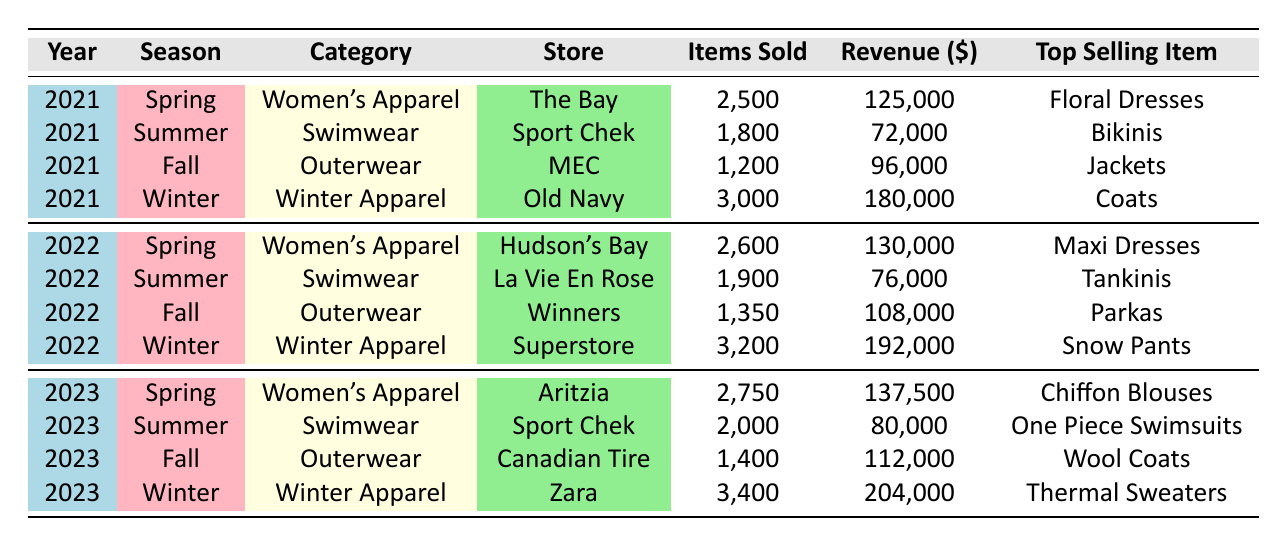What was the top-selling item in Winter 2022? According to the table, in Winter 2022, the top-selling item was "Snow Pants" sold at Superstore.
Answer: Snow Pants How many items of Women’s Apparel were sold in Spring 2023? The table indicates that in Spring 2023, 2,750 items of Women's Apparel were sold at Aritzia.
Answer: 2750 Which store sold the highest number of swimwear items in Summer 2023? In Summer 2023, Sport Chek sold 2,000 items of swimwear, which is the highest among the listed stores for that season.
Answer: Sport Chek What is the total revenue generated from Winter Apparel over the three years? Summing the revenue from Winter Apparel: 180,000 (2021) + 192,000 (2022) + 204,000 (2023) = 576,000. The total revenue generated is 576,000.
Answer: 576000 Did The Bay sell more items in Spring 2021 than Hudson's Bay in Spring 2022? The Bay sold 2,500 items in Spring 2021 while Hudson's Bay sold 2,600 items in Spring 2022. Since 2,600 is greater than 2,500, the statement is false.
Answer: No What was the average number of items sold across all seasons in 2021? The total items sold in 2021: 2,500 (Spring) + 1,800 (Summer) + 1,200 (Fall) + 3,000 (Winter) = 8,500, which divided by 4 seasons gives an average of 2,125.
Answer: 2125 In which season did Canadian Tire sell the fewest items in 2023? In 2023, Canadian Tire sold 1,400 items in Fall, which is fewer than the items sold in Spring (2,750), Summer (2,000), or Winter (3,400).
Answer: Fall Is the average price of swimwear the same in Summer 2021 and Summer 2022? The average price of swimwear in Summer 2021 is $40, and in Summer 2022 it is also $40; therefore, they are the same. The statement is true.
Answer: Yes Which season had the highest revenue overall in 2022? In 2022, Winter generated the highest revenue at $192,000, compared to Spring ($130,000), Summer ($76,000), and Fall ($108,000).
Answer: Winter 